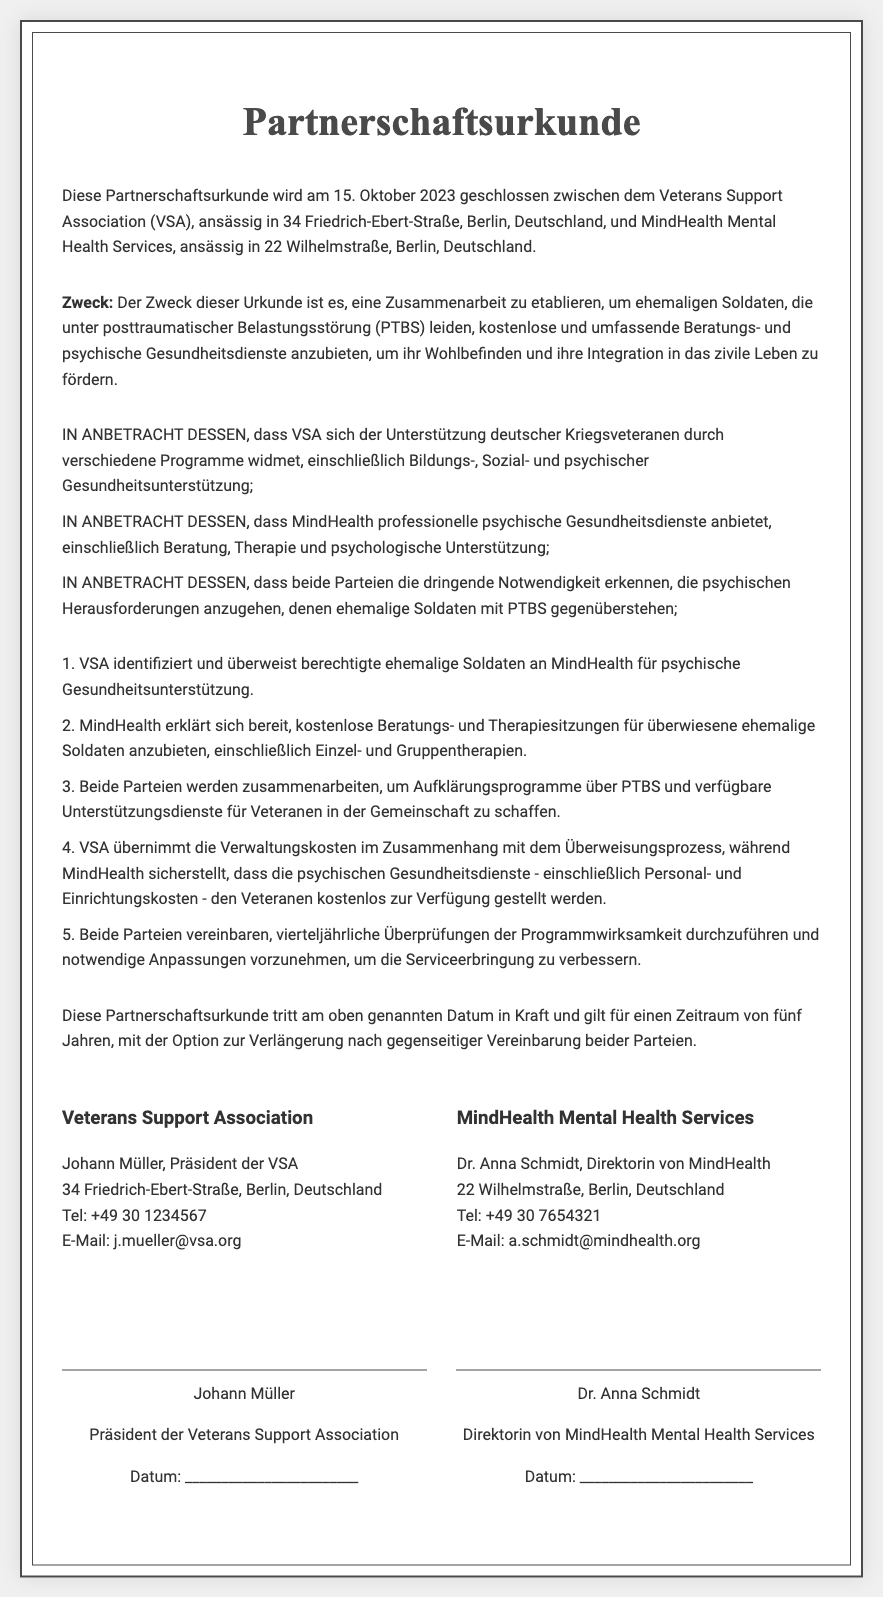Was ist das Datum der Unterzeichnung? Das Datum der Unterzeichnung ist im Einleitungsteil des Dokuments angegeben.
Answer: 15. Oktober 2023 Wer ist der Präsident der Veterans Support Association? Der Präsident ist im Kontaktteil des Dokuments aufgeführt.
Answer: Johann Müller Welche Organisation bietet psychische Gesundheitsdienste an? Die Organisation, die psychische Gesundheitsdienste anbietet, wird im Einleitungsteil des Dokuments genannt.
Answer: MindHealth Mental Health Services Was ist der Zweck der Partnerschaft? Der Zweck wird im Abschnit "Zweck" erläutert.
Answer: kostenlose und umfassende Beratungs- und psychische Gesundheitsdienste Wie lange gilt die Partnerschaft? Die Gültigkeitsdauer der Partnerschaft wird im Abschnitt "Terms" erwähnt.
Answer: fünf Jahre Wer ist die Direktorin von MindHealth? Die Direktorin wird im Kontaktteil des Dokuments genannt.
Answer: Dr. Anna Schmidt Was umfasst das Angebot von MindHealth? Das Angebot wird im Abschnitt "Agreements" beschrieben.
Answer: kostenlose Beratungs- und Therapiesitzungen Was verpflichtet die VSA zu tun? Die Verpflichtung der VSA wird im Abschnitt "Agreements" spezifiziert.
Answer: identifiziert und überweist berechtigte ehemalige Soldaten Wie oft werden Programmüberprüfungen durchgeführt? Die Frequenz der Überprüfungen wird im Abschnitt "Agreements" erwähnt.
Answer: vierteljährlich 